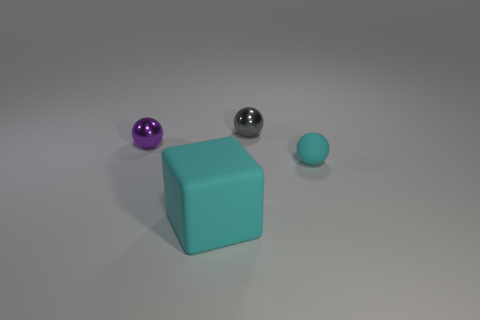Is there anything else that is the same size as the matte cube?
Offer a very short reply. No. What shape is the other matte object that is the same color as the large matte object?
Your answer should be compact. Sphere. What color is the small object that is to the left of the small thing that is behind the tiny purple metallic object?
Your answer should be very brief. Purple. Do the shiny ball that is right of the small purple shiny ball and the tiny matte ball have the same color?
Give a very brief answer. No. There is a matte thing that is on the right side of the tiny shiny thing that is to the right of the cyan rubber object left of the gray metallic object; what shape is it?
Provide a succinct answer. Sphere. What number of purple things are to the left of the cyan rubber object that is to the right of the gray ball?
Ensure brevity in your answer.  1. Is the material of the large cyan block the same as the tiny gray object?
Ensure brevity in your answer.  No. What number of tiny shiny balls are right of the small sphere that is to the left of the cyan matte thing in front of the tiny rubber sphere?
Offer a terse response. 1. What is the color of the metallic ball left of the gray thing?
Make the answer very short. Purple. What shape is the thing that is behind the purple shiny thing that is left of the large cube?
Ensure brevity in your answer.  Sphere. 